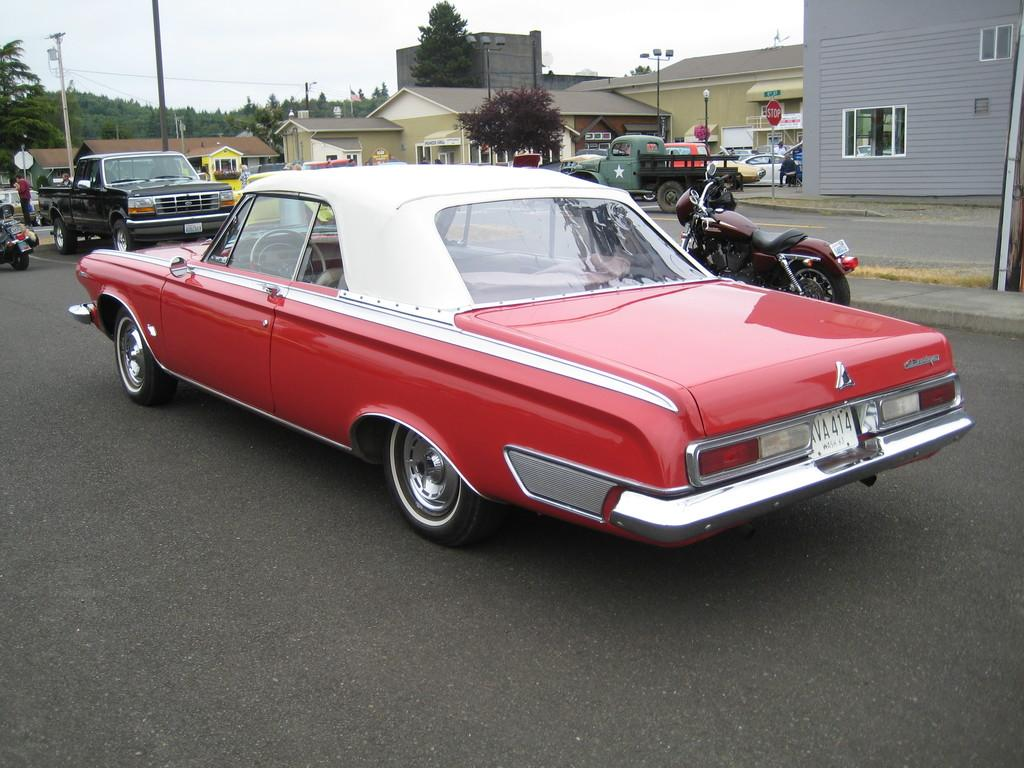What color is the car that is visible on the road in the image? There is a red color car on the road in the image. What can be seen around the red car on the road? There are other vehicles in front and beside the red car. What is located in the right corner of the image? There are buildings in the right corner of the image. What type of natural scenery is visible in the background of the image? There are trees in the background of the image. Can you tell me how much honey is in the jar on the van in the image? There is no van or jar of honey present in the image. What type of shade is provided by the trees in the image? There is no mention of shade in the image; it only shows trees in the background. 